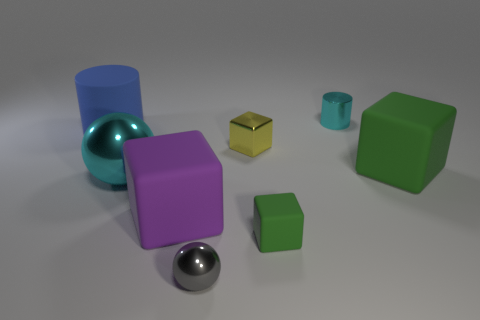There is a big matte cube right of the small rubber cube; does it have the same color as the tiny metal block?
Keep it short and to the point. No. The tiny cyan object that is made of the same material as the yellow thing is what shape?
Give a very brief answer. Cylinder. What is the color of the tiny metallic object that is behind the tiny green block and on the left side of the tiny cyan shiny object?
Give a very brief answer. Yellow. There is a green block that is in front of the cyan metal thing that is in front of the tiny cyan thing; how big is it?
Give a very brief answer. Small. Are there any large spheres of the same color as the tiny metallic cylinder?
Your response must be concise. Yes. Are there the same number of big matte things left of the small green thing and tiny red cylinders?
Offer a terse response. No. What number of tiny blue metallic things are there?
Your response must be concise. 0. What shape is the small thing that is behind the tiny green matte cube and in front of the blue rubber cylinder?
Keep it short and to the point. Cube. Does the shiny thing behind the blue matte cylinder have the same color as the large block on the right side of the tiny cylinder?
Provide a short and direct response. No. The sphere that is the same color as the small metal cylinder is what size?
Keep it short and to the point. Large. 